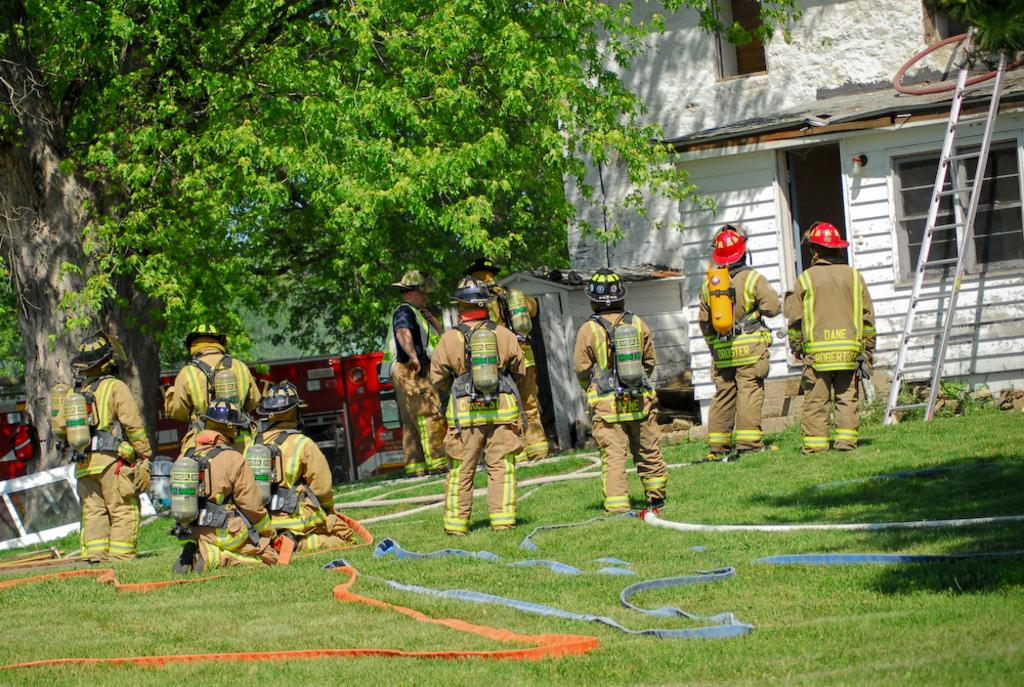What type of professionals are present in the image? There are firemen in the image. What are the firemen holding in the image? The firemen are holding pipes. What can be seen in the background of the image? There is a tree and a house in the background of the image. What equipment is present near the house? A ladder is present near the house. Can you tell me how many cubs are playing near the ocean in the image? There is no ocean or cubs present in the image; it features firemen holding pipes and a house in the background. 